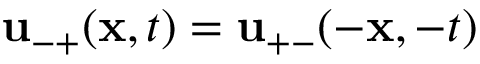<formula> <loc_0><loc_0><loc_500><loc_500>{ u } _ { - + } ( { x } , t ) = { u } _ { + - } ( - { x } , - t )</formula> 